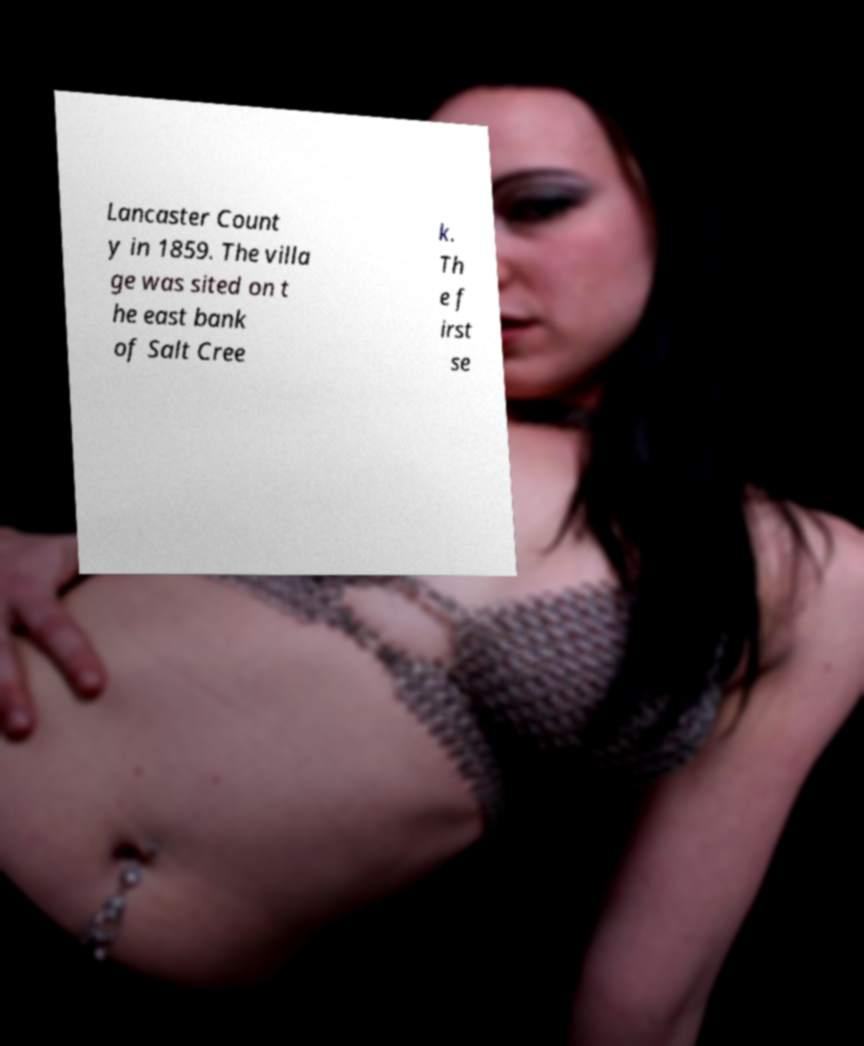I need the written content from this picture converted into text. Can you do that? Lancaster Count y in 1859. The villa ge was sited on t he east bank of Salt Cree k. Th e f irst se 